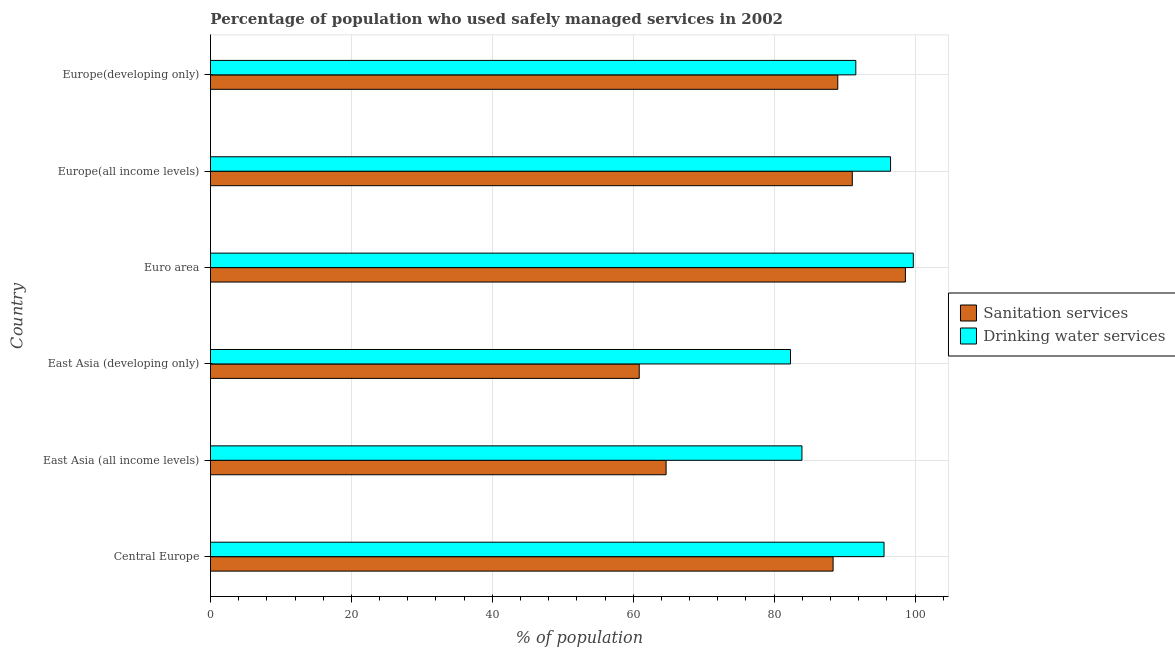Are the number of bars per tick equal to the number of legend labels?
Your answer should be very brief. Yes. How many bars are there on the 5th tick from the bottom?
Your answer should be very brief. 2. What is the label of the 4th group of bars from the top?
Your answer should be very brief. East Asia (developing only). In how many cases, is the number of bars for a given country not equal to the number of legend labels?
Your answer should be very brief. 0. What is the percentage of population who used drinking water services in East Asia (all income levels)?
Offer a terse response. 83.95. Across all countries, what is the maximum percentage of population who used sanitation services?
Provide a succinct answer. 98.63. Across all countries, what is the minimum percentage of population who used drinking water services?
Offer a very short reply. 82.32. In which country was the percentage of population who used drinking water services minimum?
Your response must be concise. East Asia (developing only). What is the total percentage of population who used drinking water services in the graph?
Provide a succinct answer. 549.73. What is the difference between the percentage of population who used drinking water services in East Asia (all income levels) and that in Europe(all income levels)?
Your answer should be compact. -12.57. What is the difference between the percentage of population who used drinking water services in Central Europe and the percentage of population who used sanitation services in Euro area?
Make the answer very short. -3.03. What is the average percentage of population who used drinking water services per country?
Give a very brief answer. 91.62. What is the difference between the percentage of population who used sanitation services and percentage of population who used drinking water services in Europe(developing only)?
Offer a very short reply. -2.56. In how many countries, is the percentage of population who used drinking water services greater than 4 %?
Ensure brevity in your answer.  6. What is the ratio of the percentage of population who used sanitation services in East Asia (developing only) to that in Euro area?
Offer a very short reply. 0.62. Is the difference between the percentage of population who used drinking water services in East Asia (developing only) and Europe(all income levels) greater than the difference between the percentage of population who used sanitation services in East Asia (developing only) and Europe(all income levels)?
Give a very brief answer. Yes. What is the difference between the highest and the second highest percentage of population who used sanitation services?
Make the answer very short. 7.54. What is the difference between the highest and the lowest percentage of population who used sanitation services?
Give a very brief answer. 37.78. In how many countries, is the percentage of population who used sanitation services greater than the average percentage of population who used sanitation services taken over all countries?
Provide a succinct answer. 4. What does the 2nd bar from the top in Europe(all income levels) represents?
Your answer should be very brief. Sanitation services. What does the 1st bar from the bottom in Euro area represents?
Keep it short and to the point. Sanitation services. Are all the bars in the graph horizontal?
Your response must be concise. Yes. What is the difference between two consecutive major ticks on the X-axis?
Make the answer very short. 20. Does the graph contain any zero values?
Keep it short and to the point. No. Does the graph contain grids?
Your response must be concise. Yes. Where does the legend appear in the graph?
Make the answer very short. Center right. How many legend labels are there?
Your answer should be very brief. 2. How are the legend labels stacked?
Provide a short and direct response. Vertical. What is the title of the graph?
Your answer should be very brief. Percentage of population who used safely managed services in 2002. What is the label or title of the X-axis?
Ensure brevity in your answer.  % of population. What is the % of population in Sanitation services in Central Europe?
Give a very brief answer. 88.37. What is the % of population of Drinking water services in Central Europe?
Make the answer very short. 95.6. What is the % of population of Sanitation services in East Asia (all income levels)?
Your answer should be compact. 64.66. What is the % of population in Drinking water services in East Asia (all income levels)?
Offer a terse response. 83.95. What is the % of population in Sanitation services in East Asia (developing only)?
Offer a very short reply. 60.85. What is the % of population of Drinking water services in East Asia (developing only)?
Provide a succinct answer. 82.32. What is the % of population in Sanitation services in Euro area?
Your answer should be compact. 98.63. What is the % of population of Drinking water services in Euro area?
Keep it short and to the point. 99.75. What is the % of population of Sanitation services in Europe(all income levels)?
Offer a very short reply. 91.09. What is the % of population in Drinking water services in Europe(all income levels)?
Offer a very short reply. 96.52. What is the % of population of Sanitation services in Europe(developing only)?
Your response must be concise. 89.03. What is the % of population of Drinking water services in Europe(developing only)?
Your response must be concise. 91.59. Across all countries, what is the maximum % of population of Sanitation services?
Give a very brief answer. 98.63. Across all countries, what is the maximum % of population of Drinking water services?
Offer a very short reply. 99.75. Across all countries, what is the minimum % of population in Sanitation services?
Your response must be concise. 60.85. Across all countries, what is the minimum % of population of Drinking water services?
Give a very brief answer. 82.32. What is the total % of population of Sanitation services in the graph?
Make the answer very short. 492.64. What is the total % of population of Drinking water services in the graph?
Provide a short and direct response. 549.73. What is the difference between the % of population in Sanitation services in Central Europe and that in East Asia (all income levels)?
Provide a short and direct response. 23.7. What is the difference between the % of population of Drinking water services in Central Europe and that in East Asia (all income levels)?
Keep it short and to the point. 11.65. What is the difference between the % of population of Sanitation services in Central Europe and that in East Asia (developing only)?
Your answer should be very brief. 27.52. What is the difference between the % of population of Drinking water services in Central Europe and that in East Asia (developing only)?
Offer a terse response. 13.28. What is the difference between the % of population of Sanitation services in Central Europe and that in Euro area?
Provide a succinct answer. -10.26. What is the difference between the % of population of Drinking water services in Central Europe and that in Euro area?
Your answer should be compact. -4.15. What is the difference between the % of population in Sanitation services in Central Europe and that in Europe(all income levels)?
Give a very brief answer. -2.72. What is the difference between the % of population of Drinking water services in Central Europe and that in Europe(all income levels)?
Your answer should be compact. -0.92. What is the difference between the % of population in Sanitation services in Central Europe and that in Europe(developing only)?
Make the answer very short. -0.67. What is the difference between the % of population of Drinking water services in Central Europe and that in Europe(developing only)?
Your answer should be compact. 4.01. What is the difference between the % of population of Sanitation services in East Asia (all income levels) and that in East Asia (developing only)?
Your answer should be compact. 3.81. What is the difference between the % of population of Drinking water services in East Asia (all income levels) and that in East Asia (developing only)?
Make the answer very short. 1.63. What is the difference between the % of population in Sanitation services in East Asia (all income levels) and that in Euro area?
Provide a short and direct response. -33.97. What is the difference between the % of population in Drinking water services in East Asia (all income levels) and that in Euro area?
Your answer should be compact. -15.81. What is the difference between the % of population of Sanitation services in East Asia (all income levels) and that in Europe(all income levels)?
Give a very brief answer. -26.43. What is the difference between the % of population in Drinking water services in East Asia (all income levels) and that in Europe(all income levels)?
Keep it short and to the point. -12.57. What is the difference between the % of population in Sanitation services in East Asia (all income levels) and that in Europe(developing only)?
Offer a terse response. -24.37. What is the difference between the % of population in Drinking water services in East Asia (all income levels) and that in Europe(developing only)?
Make the answer very short. -7.65. What is the difference between the % of population of Sanitation services in East Asia (developing only) and that in Euro area?
Your answer should be very brief. -37.78. What is the difference between the % of population of Drinking water services in East Asia (developing only) and that in Euro area?
Offer a very short reply. -17.43. What is the difference between the % of population of Sanitation services in East Asia (developing only) and that in Europe(all income levels)?
Make the answer very short. -30.24. What is the difference between the % of population in Drinking water services in East Asia (developing only) and that in Europe(all income levels)?
Keep it short and to the point. -14.2. What is the difference between the % of population in Sanitation services in East Asia (developing only) and that in Europe(developing only)?
Provide a succinct answer. -28.18. What is the difference between the % of population of Drinking water services in East Asia (developing only) and that in Europe(developing only)?
Offer a terse response. -9.27. What is the difference between the % of population in Sanitation services in Euro area and that in Europe(all income levels)?
Make the answer very short. 7.54. What is the difference between the % of population of Drinking water services in Euro area and that in Europe(all income levels)?
Offer a terse response. 3.23. What is the difference between the % of population of Sanitation services in Euro area and that in Europe(developing only)?
Your answer should be compact. 9.6. What is the difference between the % of population in Drinking water services in Euro area and that in Europe(developing only)?
Your answer should be very brief. 8.16. What is the difference between the % of population in Sanitation services in Europe(all income levels) and that in Europe(developing only)?
Give a very brief answer. 2.06. What is the difference between the % of population in Drinking water services in Europe(all income levels) and that in Europe(developing only)?
Give a very brief answer. 4.93. What is the difference between the % of population of Sanitation services in Central Europe and the % of population of Drinking water services in East Asia (all income levels)?
Offer a very short reply. 4.42. What is the difference between the % of population in Sanitation services in Central Europe and the % of population in Drinking water services in East Asia (developing only)?
Make the answer very short. 6.05. What is the difference between the % of population in Sanitation services in Central Europe and the % of population in Drinking water services in Euro area?
Give a very brief answer. -11.39. What is the difference between the % of population of Sanitation services in Central Europe and the % of population of Drinking water services in Europe(all income levels)?
Your response must be concise. -8.15. What is the difference between the % of population of Sanitation services in Central Europe and the % of population of Drinking water services in Europe(developing only)?
Offer a very short reply. -3.22. What is the difference between the % of population of Sanitation services in East Asia (all income levels) and the % of population of Drinking water services in East Asia (developing only)?
Provide a succinct answer. -17.66. What is the difference between the % of population of Sanitation services in East Asia (all income levels) and the % of population of Drinking water services in Euro area?
Your answer should be compact. -35.09. What is the difference between the % of population of Sanitation services in East Asia (all income levels) and the % of population of Drinking water services in Europe(all income levels)?
Offer a very short reply. -31.86. What is the difference between the % of population in Sanitation services in East Asia (all income levels) and the % of population in Drinking water services in Europe(developing only)?
Provide a succinct answer. -26.93. What is the difference between the % of population in Sanitation services in East Asia (developing only) and the % of population in Drinking water services in Euro area?
Provide a succinct answer. -38.9. What is the difference between the % of population of Sanitation services in East Asia (developing only) and the % of population of Drinking water services in Europe(all income levels)?
Your answer should be compact. -35.67. What is the difference between the % of population in Sanitation services in East Asia (developing only) and the % of population in Drinking water services in Europe(developing only)?
Provide a short and direct response. -30.74. What is the difference between the % of population of Sanitation services in Euro area and the % of population of Drinking water services in Europe(all income levels)?
Offer a very short reply. 2.11. What is the difference between the % of population of Sanitation services in Euro area and the % of population of Drinking water services in Europe(developing only)?
Your answer should be compact. 7.04. What is the difference between the % of population of Sanitation services in Europe(all income levels) and the % of population of Drinking water services in Europe(developing only)?
Your answer should be very brief. -0.5. What is the average % of population in Sanitation services per country?
Keep it short and to the point. 82.11. What is the average % of population of Drinking water services per country?
Offer a terse response. 91.62. What is the difference between the % of population of Sanitation services and % of population of Drinking water services in Central Europe?
Keep it short and to the point. -7.23. What is the difference between the % of population of Sanitation services and % of population of Drinking water services in East Asia (all income levels)?
Keep it short and to the point. -19.28. What is the difference between the % of population of Sanitation services and % of population of Drinking water services in East Asia (developing only)?
Offer a terse response. -21.47. What is the difference between the % of population of Sanitation services and % of population of Drinking water services in Euro area?
Give a very brief answer. -1.12. What is the difference between the % of population in Sanitation services and % of population in Drinking water services in Europe(all income levels)?
Provide a short and direct response. -5.43. What is the difference between the % of population in Sanitation services and % of population in Drinking water services in Europe(developing only)?
Provide a short and direct response. -2.56. What is the ratio of the % of population in Sanitation services in Central Europe to that in East Asia (all income levels)?
Ensure brevity in your answer.  1.37. What is the ratio of the % of population in Drinking water services in Central Europe to that in East Asia (all income levels)?
Your answer should be compact. 1.14. What is the ratio of the % of population of Sanitation services in Central Europe to that in East Asia (developing only)?
Provide a succinct answer. 1.45. What is the ratio of the % of population of Drinking water services in Central Europe to that in East Asia (developing only)?
Your answer should be very brief. 1.16. What is the ratio of the % of population of Sanitation services in Central Europe to that in Euro area?
Your answer should be compact. 0.9. What is the ratio of the % of population of Drinking water services in Central Europe to that in Euro area?
Give a very brief answer. 0.96. What is the ratio of the % of population of Sanitation services in Central Europe to that in Europe(all income levels)?
Make the answer very short. 0.97. What is the ratio of the % of population in Sanitation services in Central Europe to that in Europe(developing only)?
Offer a terse response. 0.99. What is the ratio of the % of population in Drinking water services in Central Europe to that in Europe(developing only)?
Give a very brief answer. 1.04. What is the ratio of the % of population of Sanitation services in East Asia (all income levels) to that in East Asia (developing only)?
Provide a succinct answer. 1.06. What is the ratio of the % of population of Drinking water services in East Asia (all income levels) to that in East Asia (developing only)?
Your answer should be compact. 1.02. What is the ratio of the % of population of Sanitation services in East Asia (all income levels) to that in Euro area?
Your response must be concise. 0.66. What is the ratio of the % of population of Drinking water services in East Asia (all income levels) to that in Euro area?
Provide a short and direct response. 0.84. What is the ratio of the % of population in Sanitation services in East Asia (all income levels) to that in Europe(all income levels)?
Ensure brevity in your answer.  0.71. What is the ratio of the % of population of Drinking water services in East Asia (all income levels) to that in Europe(all income levels)?
Ensure brevity in your answer.  0.87. What is the ratio of the % of population in Sanitation services in East Asia (all income levels) to that in Europe(developing only)?
Provide a succinct answer. 0.73. What is the ratio of the % of population of Drinking water services in East Asia (all income levels) to that in Europe(developing only)?
Keep it short and to the point. 0.92. What is the ratio of the % of population of Sanitation services in East Asia (developing only) to that in Euro area?
Your response must be concise. 0.62. What is the ratio of the % of population in Drinking water services in East Asia (developing only) to that in Euro area?
Provide a short and direct response. 0.83. What is the ratio of the % of population of Sanitation services in East Asia (developing only) to that in Europe(all income levels)?
Your answer should be very brief. 0.67. What is the ratio of the % of population of Drinking water services in East Asia (developing only) to that in Europe(all income levels)?
Your response must be concise. 0.85. What is the ratio of the % of population in Sanitation services in East Asia (developing only) to that in Europe(developing only)?
Your response must be concise. 0.68. What is the ratio of the % of population of Drinking water services in East Asia (developing only) to that in Europe(developing only)?
Offer a very short reply. 0.9. What is the ratio of the % of population of Sanitation services in Euro area to that in Europe(all income levels)?
Give a very brief answer. 1.08. What is the ratio of the % of population of Drinking water services in Euro area to that in Europe(all income levels)?
Your response must be concise. 1.03. What is the ratio of the % of population of Sanitation services in Euro area to that in Europe(developing only)?
Your answer should be compact. 1.11. What is the ratio of the % of population of Drinking water services in Euro area to that in Europe(developing only)?
Give a very brief answer. 1.09. What is the ratio of the % of population of Sanitation services in Europe(all income levels) to that in Europe(developing only)?
Offer a terse response. 1.02. What is the ratio of the % of population in Drinking water services in Europe(all income levels) to that in Europe(developing only)?
Offer a terse response. 1.05. What is the difference between the highest and the second highest % of population in Sanitation services?
Your answer should be very brief. 7.54. What is the difference between the highest and the second highest % of population of Drinking water services?
Provide a short and direct response. 3.23. What is the difference between the highest and the lowest % of population of Sanitation services?
Provide a succinct answer. 37.78. What is the difference between the highest and the lowest % of population of Drinking water services?
Your answer should be very brief. 17.43. 